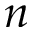<formula> <loc_0><loc_0><loc_500><loc_500>n</formula> 